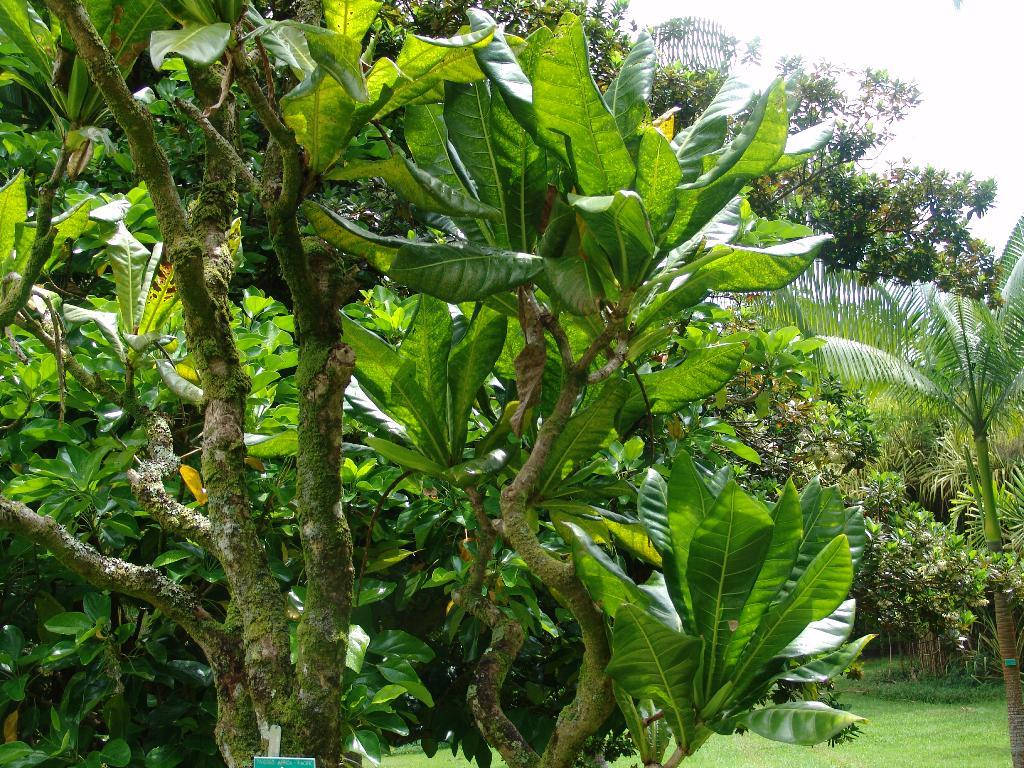What type of vegetation can be seen in the image? There are trees in the image. What part of the natural environment is visible at the bottom of the image? The ground is visible at the bottom of the image. What part of the natural environment is visible at the top of the image? The sky is visible at the top of the image. What type of cake is being copied in the image? There is no cake present in the image, nor is there any indication of copying. 